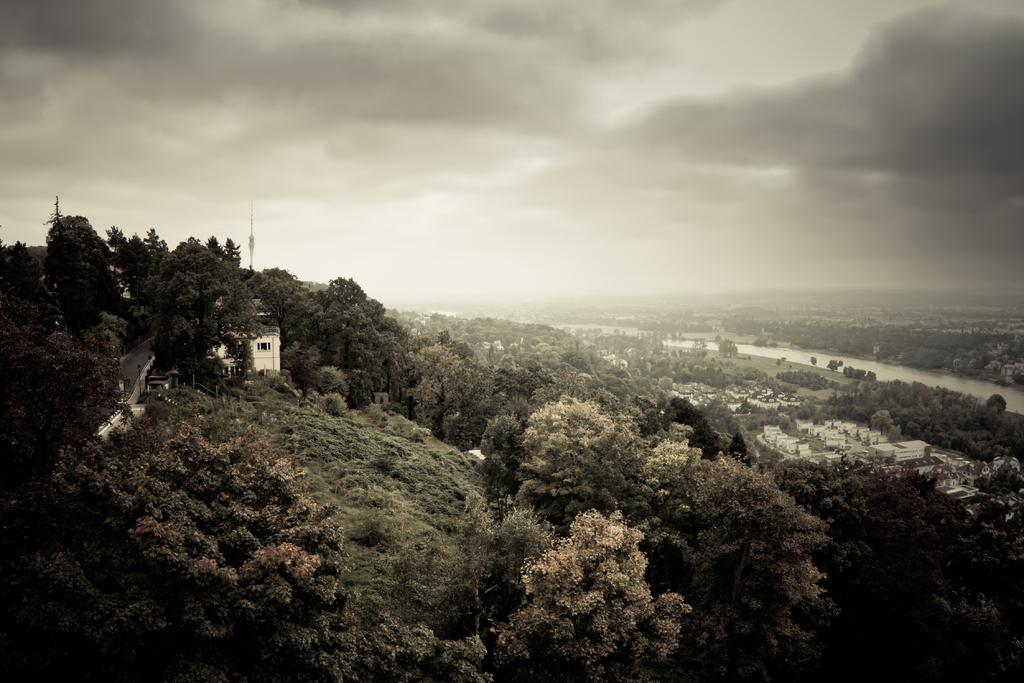What can be seen on both sides of the image? There are houses on both the right and left sides of the image. What type of environment is depicted in the image? There is greenery around the area of the image. Can you see the steam coming out of the houses in the image? There is no steam visible in the image; it depicts houses and greenery. 